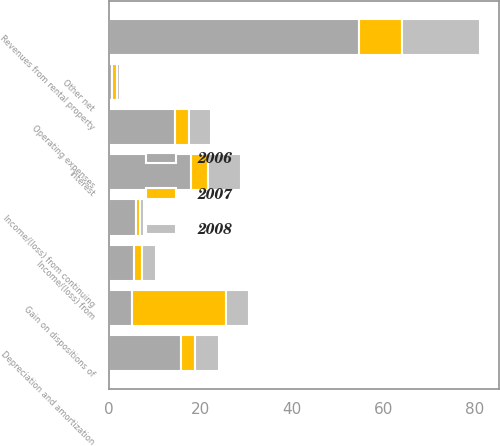<chart> <loc_0><loc_0><loc_500><loc_500><stacked_bar_chart><ecel><fcel>Revenues from rental property<fcel>Operating expenses<fcel>Interest<fcel>Depreciation and amortization<fcel>Other net<fcel>Income/(loss) from continuing<fcel>Income/(loss) from<fcel>Gain on dispositions of<nl><fcel>2007<fcel>9.4<fcel>3<fcel>3.7<fcel>3<fcel>1.1<fcel>0.8<fcel>1.7<fcel>20.5<nl><fcel>2008<fcel>17.1<fcel>4.8<fcel>7.2<fcel>5.2<fcel>0.7<fcel>0.8<fcel>3.1<fcel>5<nl><fcel>2006<fcel>54.7<fcel>14.5<fcel>17.9<fcel>15.8<fcel>0.6<fcel>5.9<fcel>5.4<fcel>5<nl></chart> 